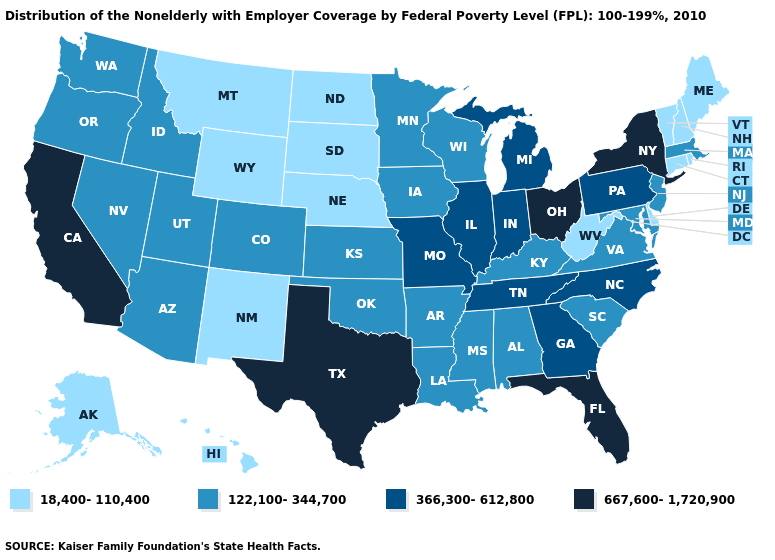Name the states that have a value in the range 122,100-344,700?
Quick response, please. Alabama, Arizona, Arkansas, Colorado, Idaho, Iowa, Kansas, Kentucky, Louisiana, Maryland, Massachusetts, Minnesota, Mississippi, Nevada, New Jersey, Oklahoma, Oregon, South Carolina, Utah, Virginia, Washington, Wisconsin. Is the legend a continuous bar?
Quick response, please. No. Name the states that have a value in the range 667,600-1,720,900?
Keep it brief. California, Florida, New York, Ohio, Texas. What is the value of Wisconsin?
Short answer required. 122,100-344,700. What is the value of Wisconsin?
Write a very short answer. 122,100-344,700. What is the highest value in the USA?
Keep it brief. 667,600-1,720,900. What is the value of Nevada?
Give a very brief answer. 122,100-344,700. What is the lowest value in the USA?
Keep it brief. 18,400-110,400. Name the states that have a value in the range 366,300-612,800?
Concise answer only. Georgia, Illinois, Indiana, Michigan, Missouri, North Carolina, Pennsylvania, Tennessee. Is the legend a continuous bar?
Short answer required. No. Name the states that have a value in the range 18,400-110,400?
Short answer required. Alaska, Connecticut, Delaware, Hawaii, Maine, Montana, Nebraska, New Hampshire, New Mexico, North Dakota, Rhode Island, South Dakota, Vermont, West Virginia, Wyoming. Does Hawaii have the lowest value in the USA?
Give a very brief answer. Yes. Which states hav the highest value in the MidWest?
Write a very short answer. Ohio. Which states have the lowest value in the USA?
Quick response, please. Alaska, Connecticut, Delaware, Hawaii, Maine, Montana, Nebraska, New Hampshire, New Mexico, North Dakota, Rhode Island, South Dakota, Vermont, West Virginia, Wyoming. Does Virginia have a higher value than New Hampshire?
Answer briefly. Yes. 